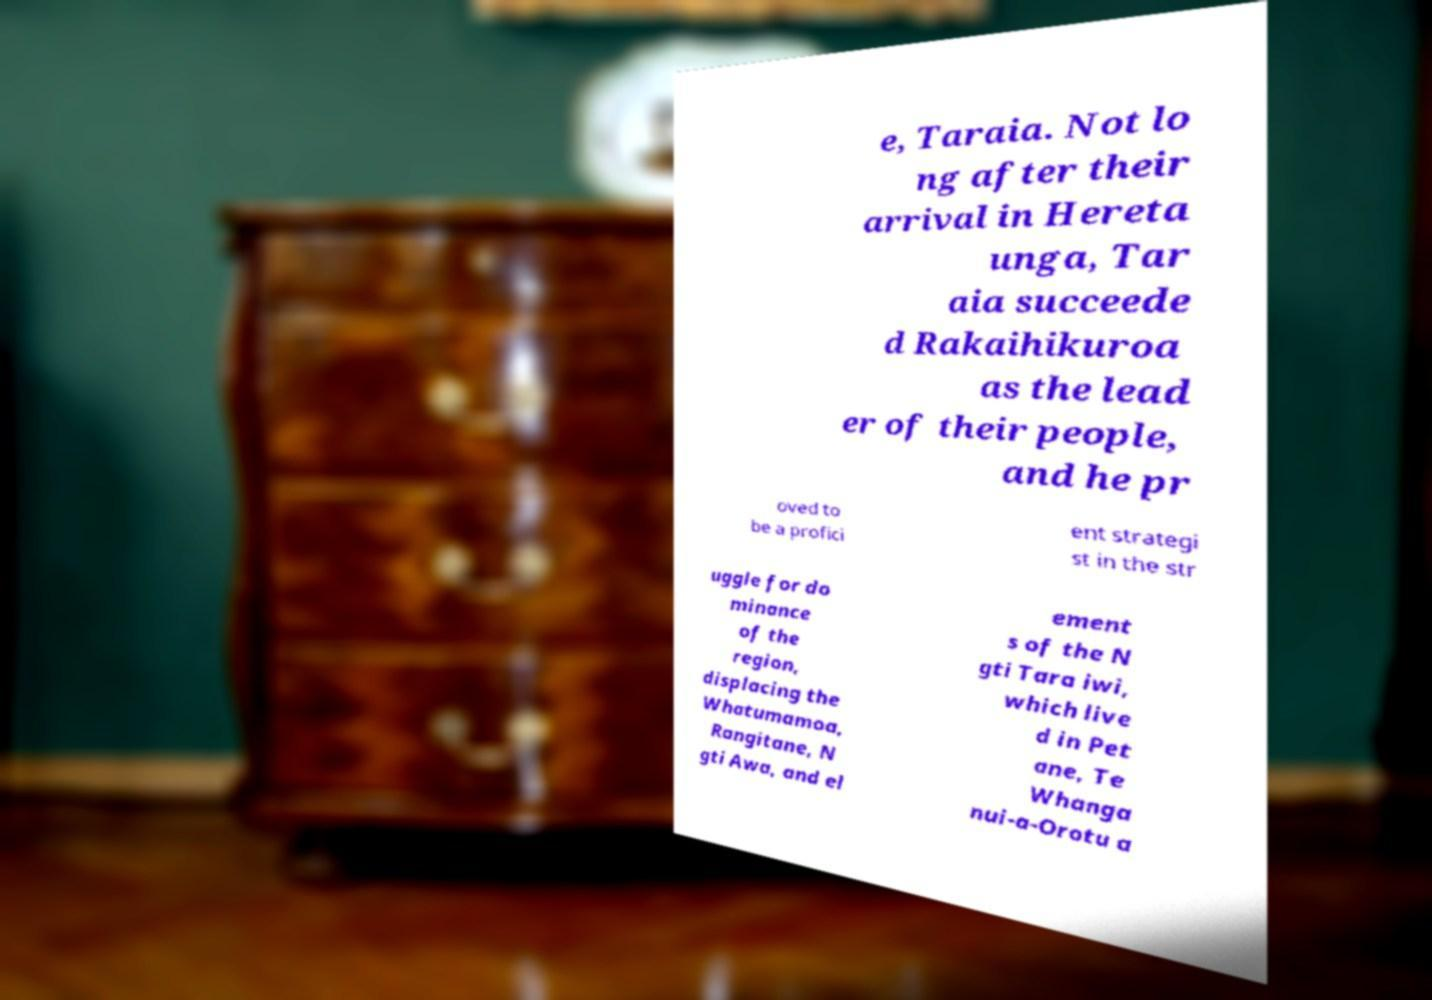I need the written content from this picture converted into text. Can you do that? e, Taraia. Not lo ng after their arrival in Hereta unga, Tar aia succeede d Rakaihikuroa as the lead er of their people, and he pr oved to be a profici ent strategi st in the str uggle for do minance of the region, displacing the Whatumamoa, Rangitane, N gti Awa, and el ement s of the N gti Tara iwi, which live d in Pet ane, Te Whanga nui-a-Orotu a 